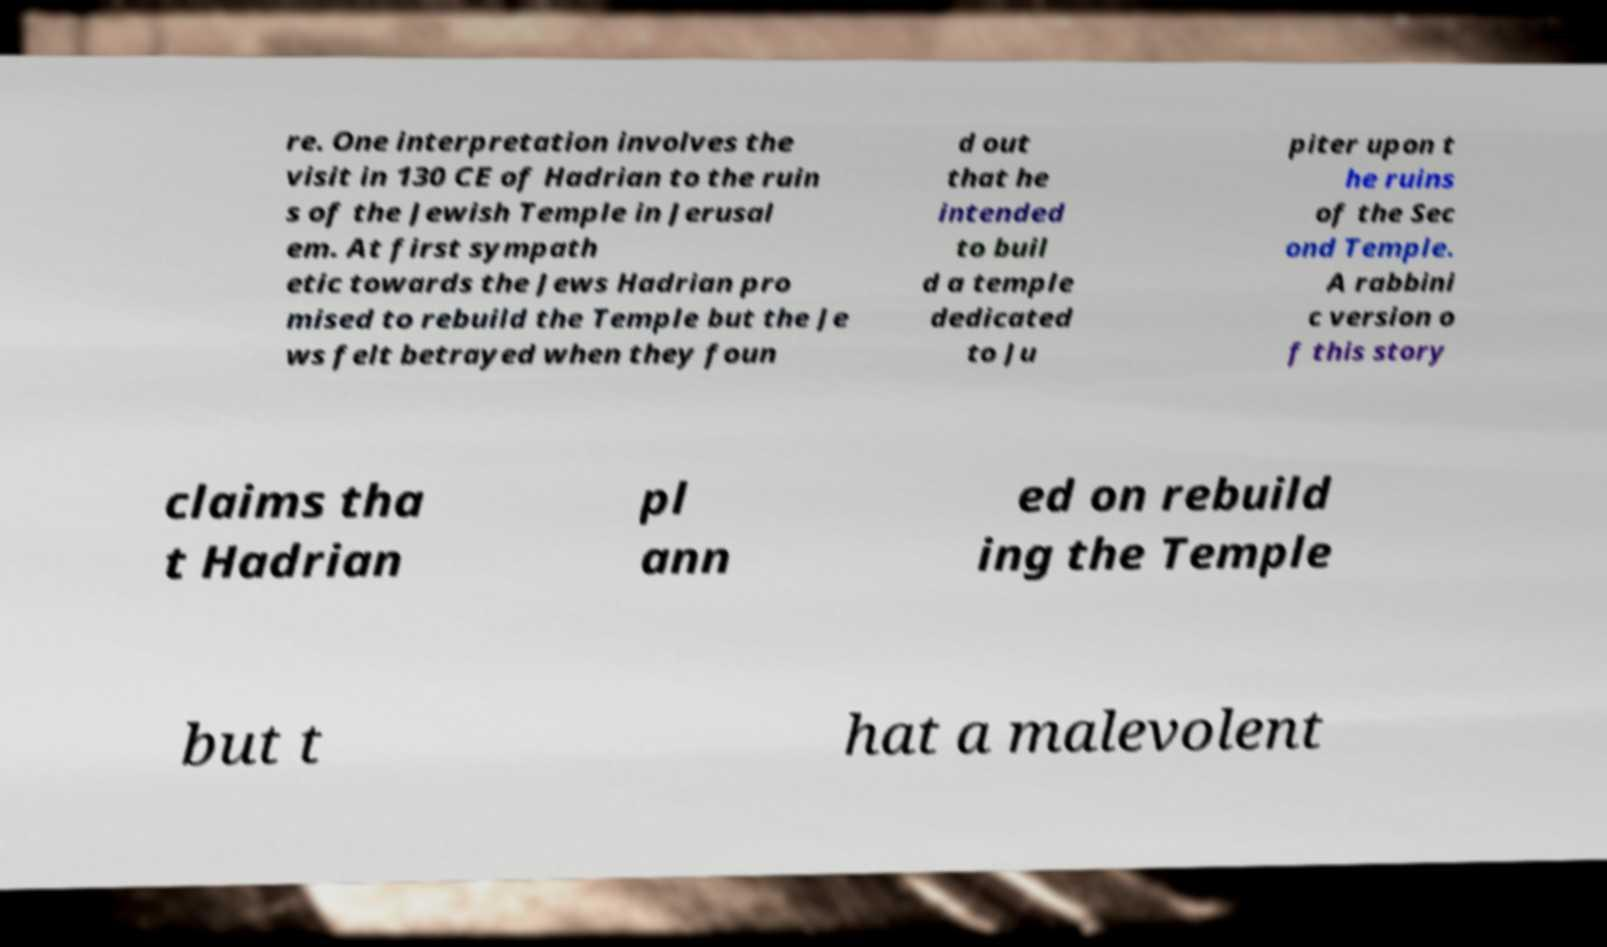For documentation purposes, I need the text within this image transcribed. Could you provide that? re. One interpretation involves the visit in 130 CE of Hadrian to the ruin s of the Jewish Temple in Jerusal em. At first sympath etic towards the Jews Hadrian pro mised to rebuild the Temple but the Je ws felt betrayed when they foun d out that he intended to buil d a temple dedicated to Ju piter upon t he ruins of the Sec ond Temple. A rabbini c version o f this story claims tha t Hadrian pl ann ed on rebuild ing the Temple but t hat a malevolent 